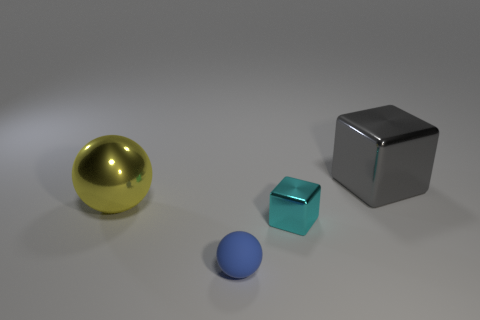Subtract all blue spheres. How many spheres are left? 1 Add 2 gray shiny objects. How many objects exist? 6 Add 4 tiny cyan metallic blocks. How many tiny cyan metallic blocks exist? 5 Subtract 0 gray spheres. How many objects are left? 4 Subtract 2 cubes. How many cubes are left? 0 Subtract all blue blocks. Subtract all cyan balls. How many blocks are left? 2 Subtract all small red rubber cylinders. Subtract all small rubber balls. How many objects are left? 3 Add 1 tiny cyan cubes. How many tiny cyan cubes are left? 2 